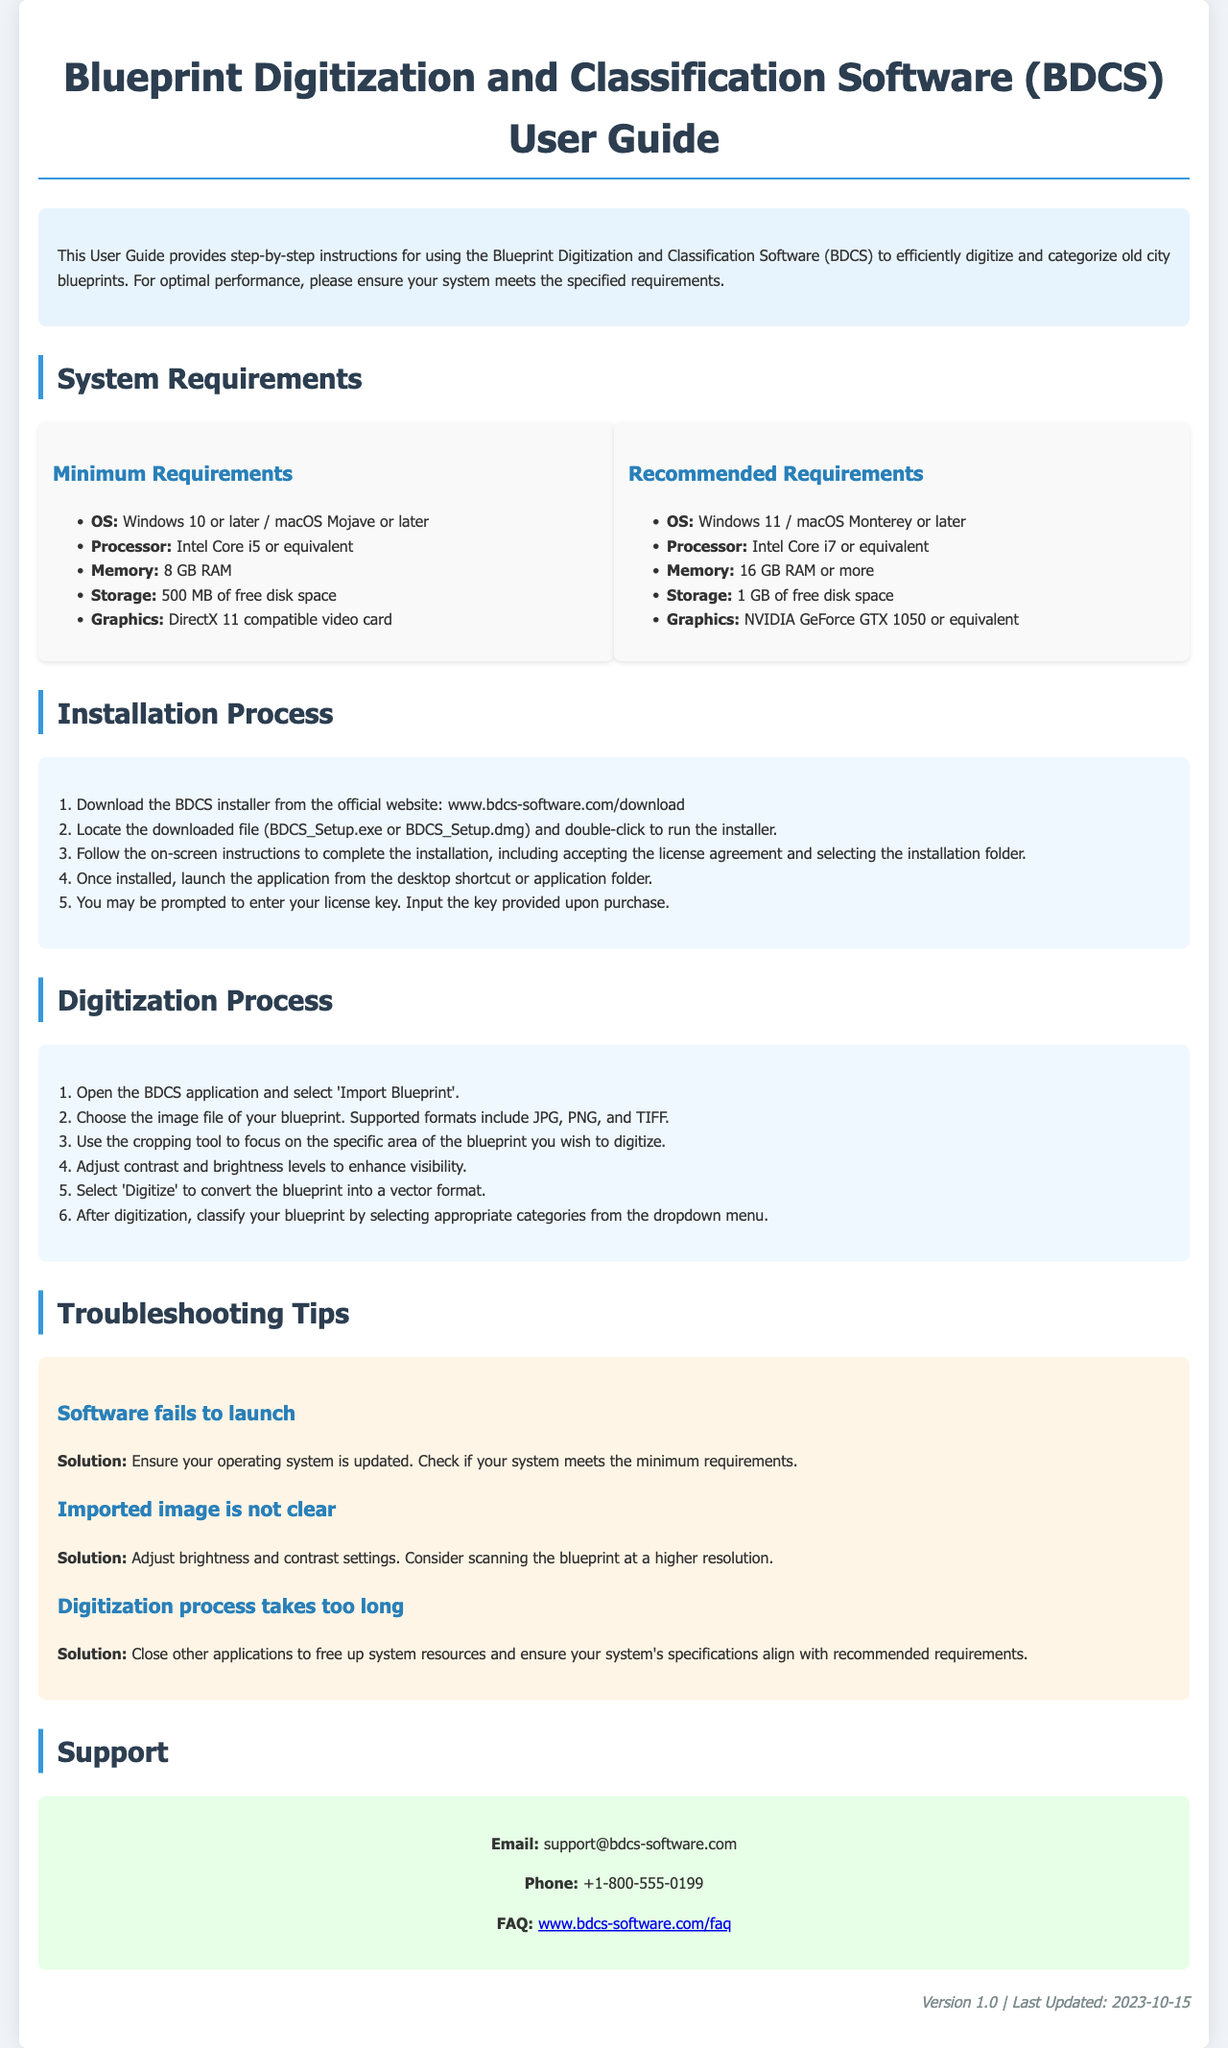What are the minimum memory requirements? The minimum memory requirement for the software is specified in the "Minimum Requirements" section.
Answer: 8 GB RAM What should you do if the software fails to launch? The troubleshooting section provides solutions for common issues, including software launch problems.
Answer: Ensure your operating system is updated How many steps are in the installation process? The installation process is detailed in its respective section and contains an ordered list of steps.
Answer: 5 steps What formats are supported for blueprint images? Supported formats are mentioned during the digitization process instructions.
Answer: JPG, PNG, TIFF What is the recommended processor for optimal performance? Recommended requirements for the software specify a processor for enhanced performance.
Answer: Intel Core i7 or equivalent What is the contact email for support? Support contact information is provided in the "Support" section of the document.
Answer: support@bdcs-software.com What is the title of the document? The title is prominently displayed at the top of the document.
Answer: Blueprint Digitization and Classification Software (BDCS) User Guide What should you check if the imported image is not clear? Solutions to common image issues are listed under troubleshooting tips.
Answer: Adjust brightness and contrast settings 